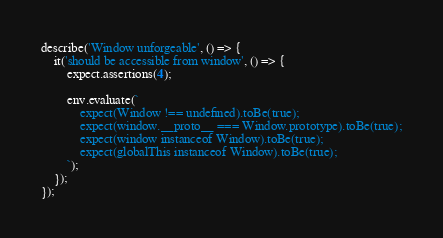Convert code to text. <code><loc_0><loc_0><loc_500><loc_500><_JavaScript_>
describe('Window unforgeable', () => {
    it('should be accessible from window', () => {
        expect.assertions(4);

        env.evaluate(`
            expect(Window !== undefined).toBe(true);
            expect(window.__proto__ === Window.prototype).toBe(true);
            expect(window instanceof Window).toBe(true);
            expect(globalThis instanceof Window).toBe(true);
        `);
    });
});
</code> 